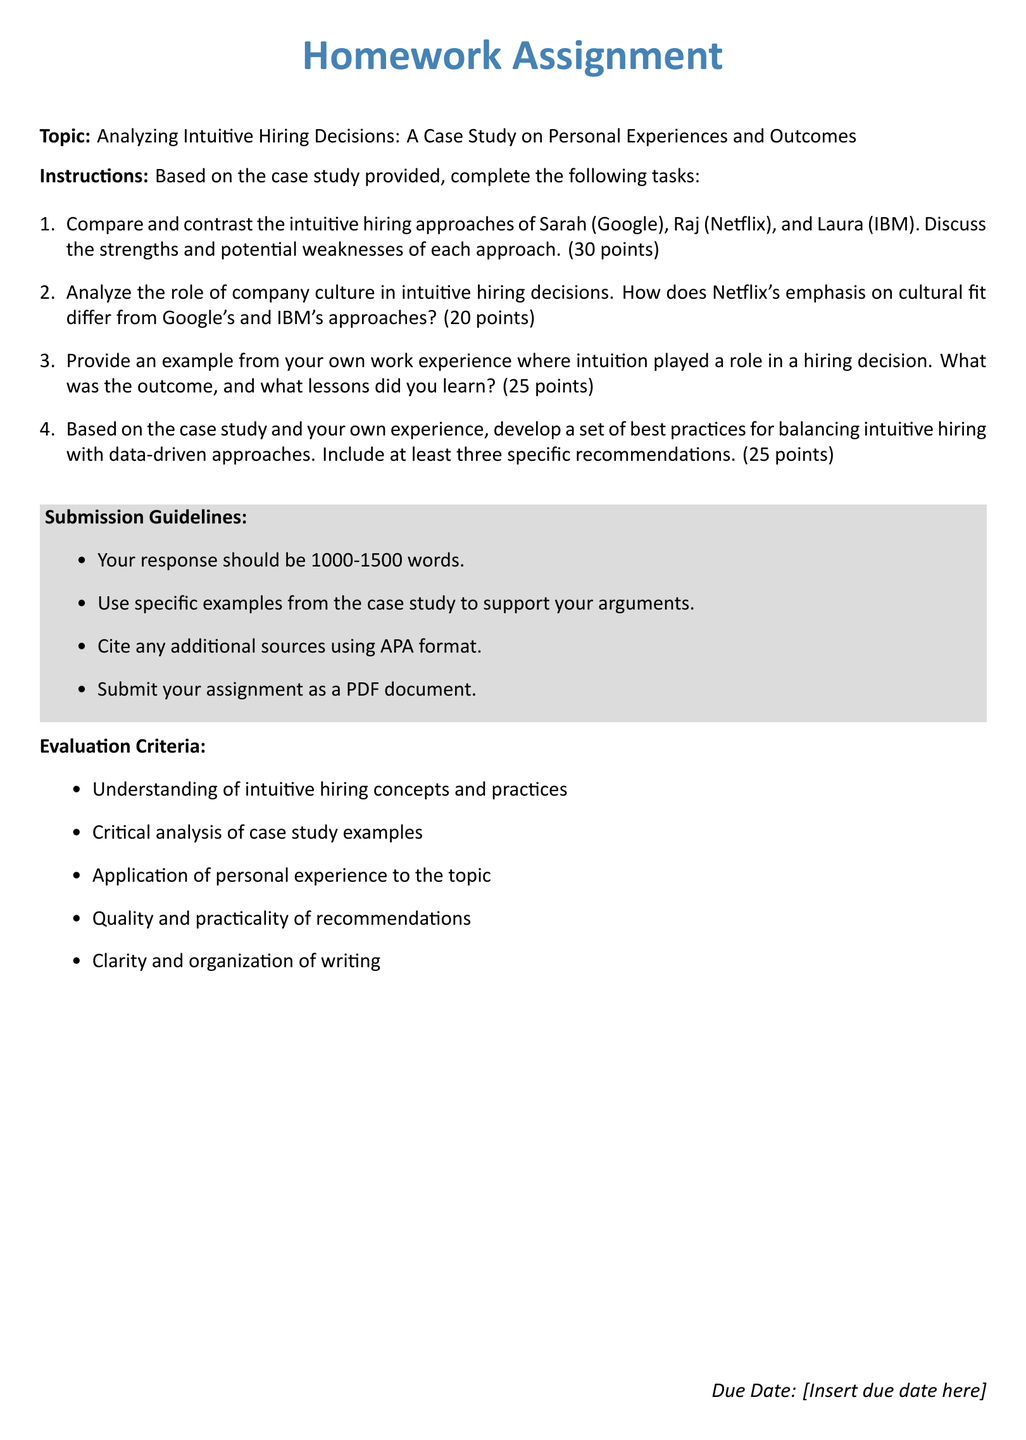What is the topic of the homework assignment? The topic is explicitly stated at the beginning of the document, which is "Analyzing Intuitive Hiring Decisions: A Case Study on Personal Experiences and Outcomes."
Answer: Analyzing Intuitive Hiring Decisions: A Case Study on Personal Experiences and Outcomes How many points is the first task worth? The task list includes point values for each task, with the first task worth 30 points.
Answer: 30 points What is the word count requirement for the response? The document specifies a required word count for the response, which is between 1000-1500 words.
Answer: 1000-1500 words What is one of the evaluation criteria? The document lists several evaluation criteria, one of which is "Understanding of intuitive hiring concepts and practices."
Answer: Understanding of intuitive hiring concepts and practices Which company emphasizes cultural fit in their hiring approach? The document notes that Netflix's emphasis on cultural fit differs from the others, indicating that Netflix focuses on it.
Answer: Netflix What is the submission deadline section labeled as? The document has a section for the submission deadline, which is labeled "Due Date."
Answer: Due Date What are students required to submit the assignment as? The submission guidelines specify that the assignment should be submitted as a PDF document.
Answer: PDF document How many specific recommendations should be included in the best practices section? The document states that at least three specific recommendations should be included in this section.
Answer: three What is the second task about? The second task asks for an analysis of the role of company culture in intuitive hiring decisions, specifically comparing Netflix to Google and IBM.
Answer: Analyze company culture in intuitive hiring decisions 